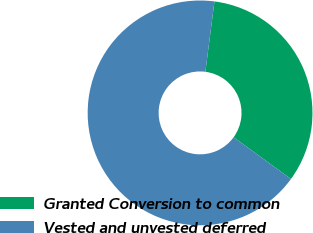<chart> <loc_0><loc_0><loc_500><loc_500><pie_chart><fcel>Granted Conversion to common<fcel>Vested and unvested deferred<nl><fcel>32.96%<fcel>67.04%<nl></chart> 